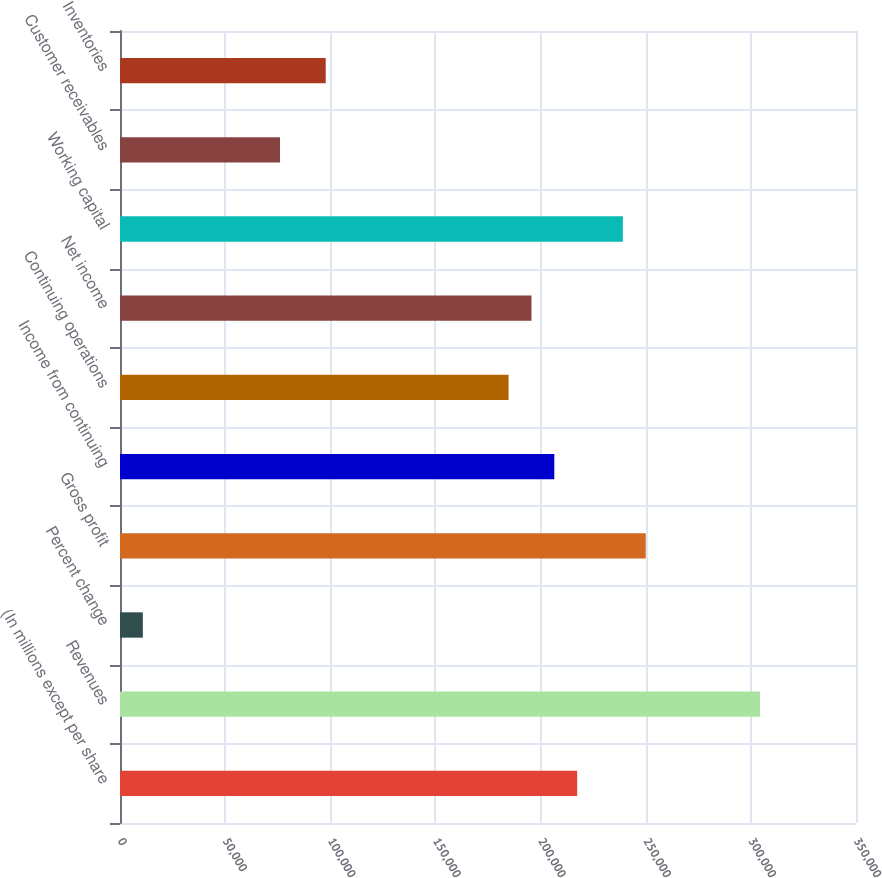Convert chart. <chart><loc_0><loc_0><loc_500><loc_500><bar_chart><fcel>(In millions except per share<fcel>Revenues<fcel>Percent change<fcel>Gross profit<fcel>Income from continuing<fcel>Continuing operations<fcel>Net income<fcel>Working capital<fcel>Customer receivables<fcel>Inventories<nl><fcel>217403<fcel>304365<fcel>10870.6<fcel>250014<fcel>206533<fcel>184793<fcel>195663<fcel>239144<fcel>76091.5<fcel>97831.8<nl></chart> 